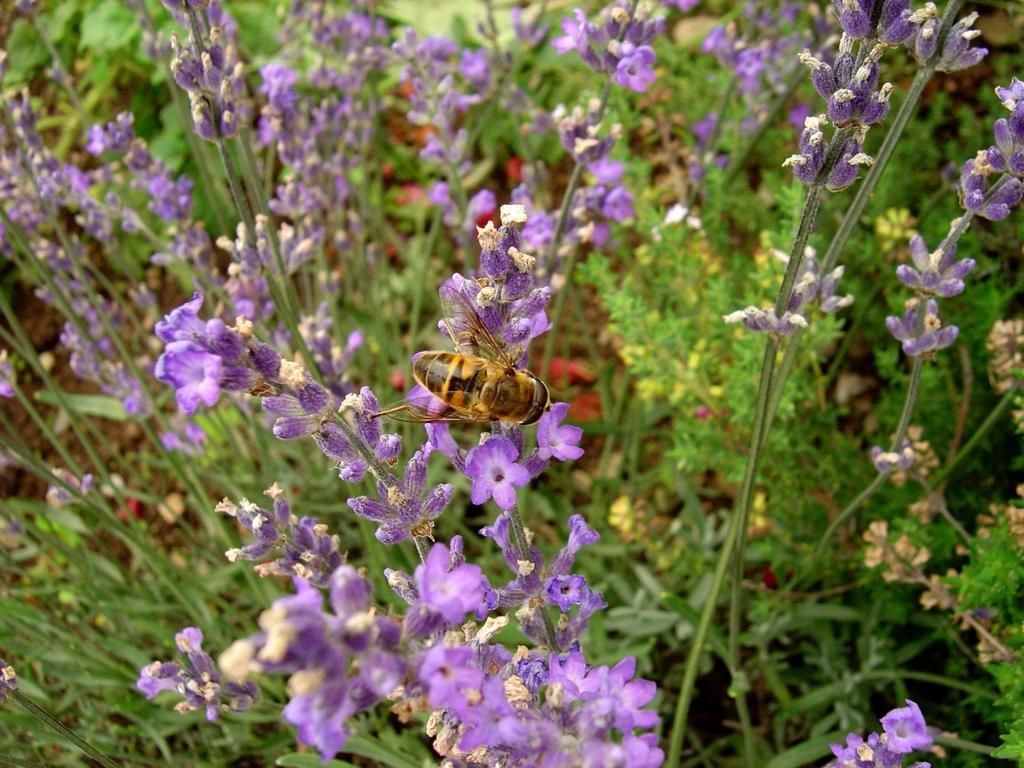Can you describe this image briefly? This image consists of plants. It has flowers. They are in purple color. There is a honey bee in the middle. 